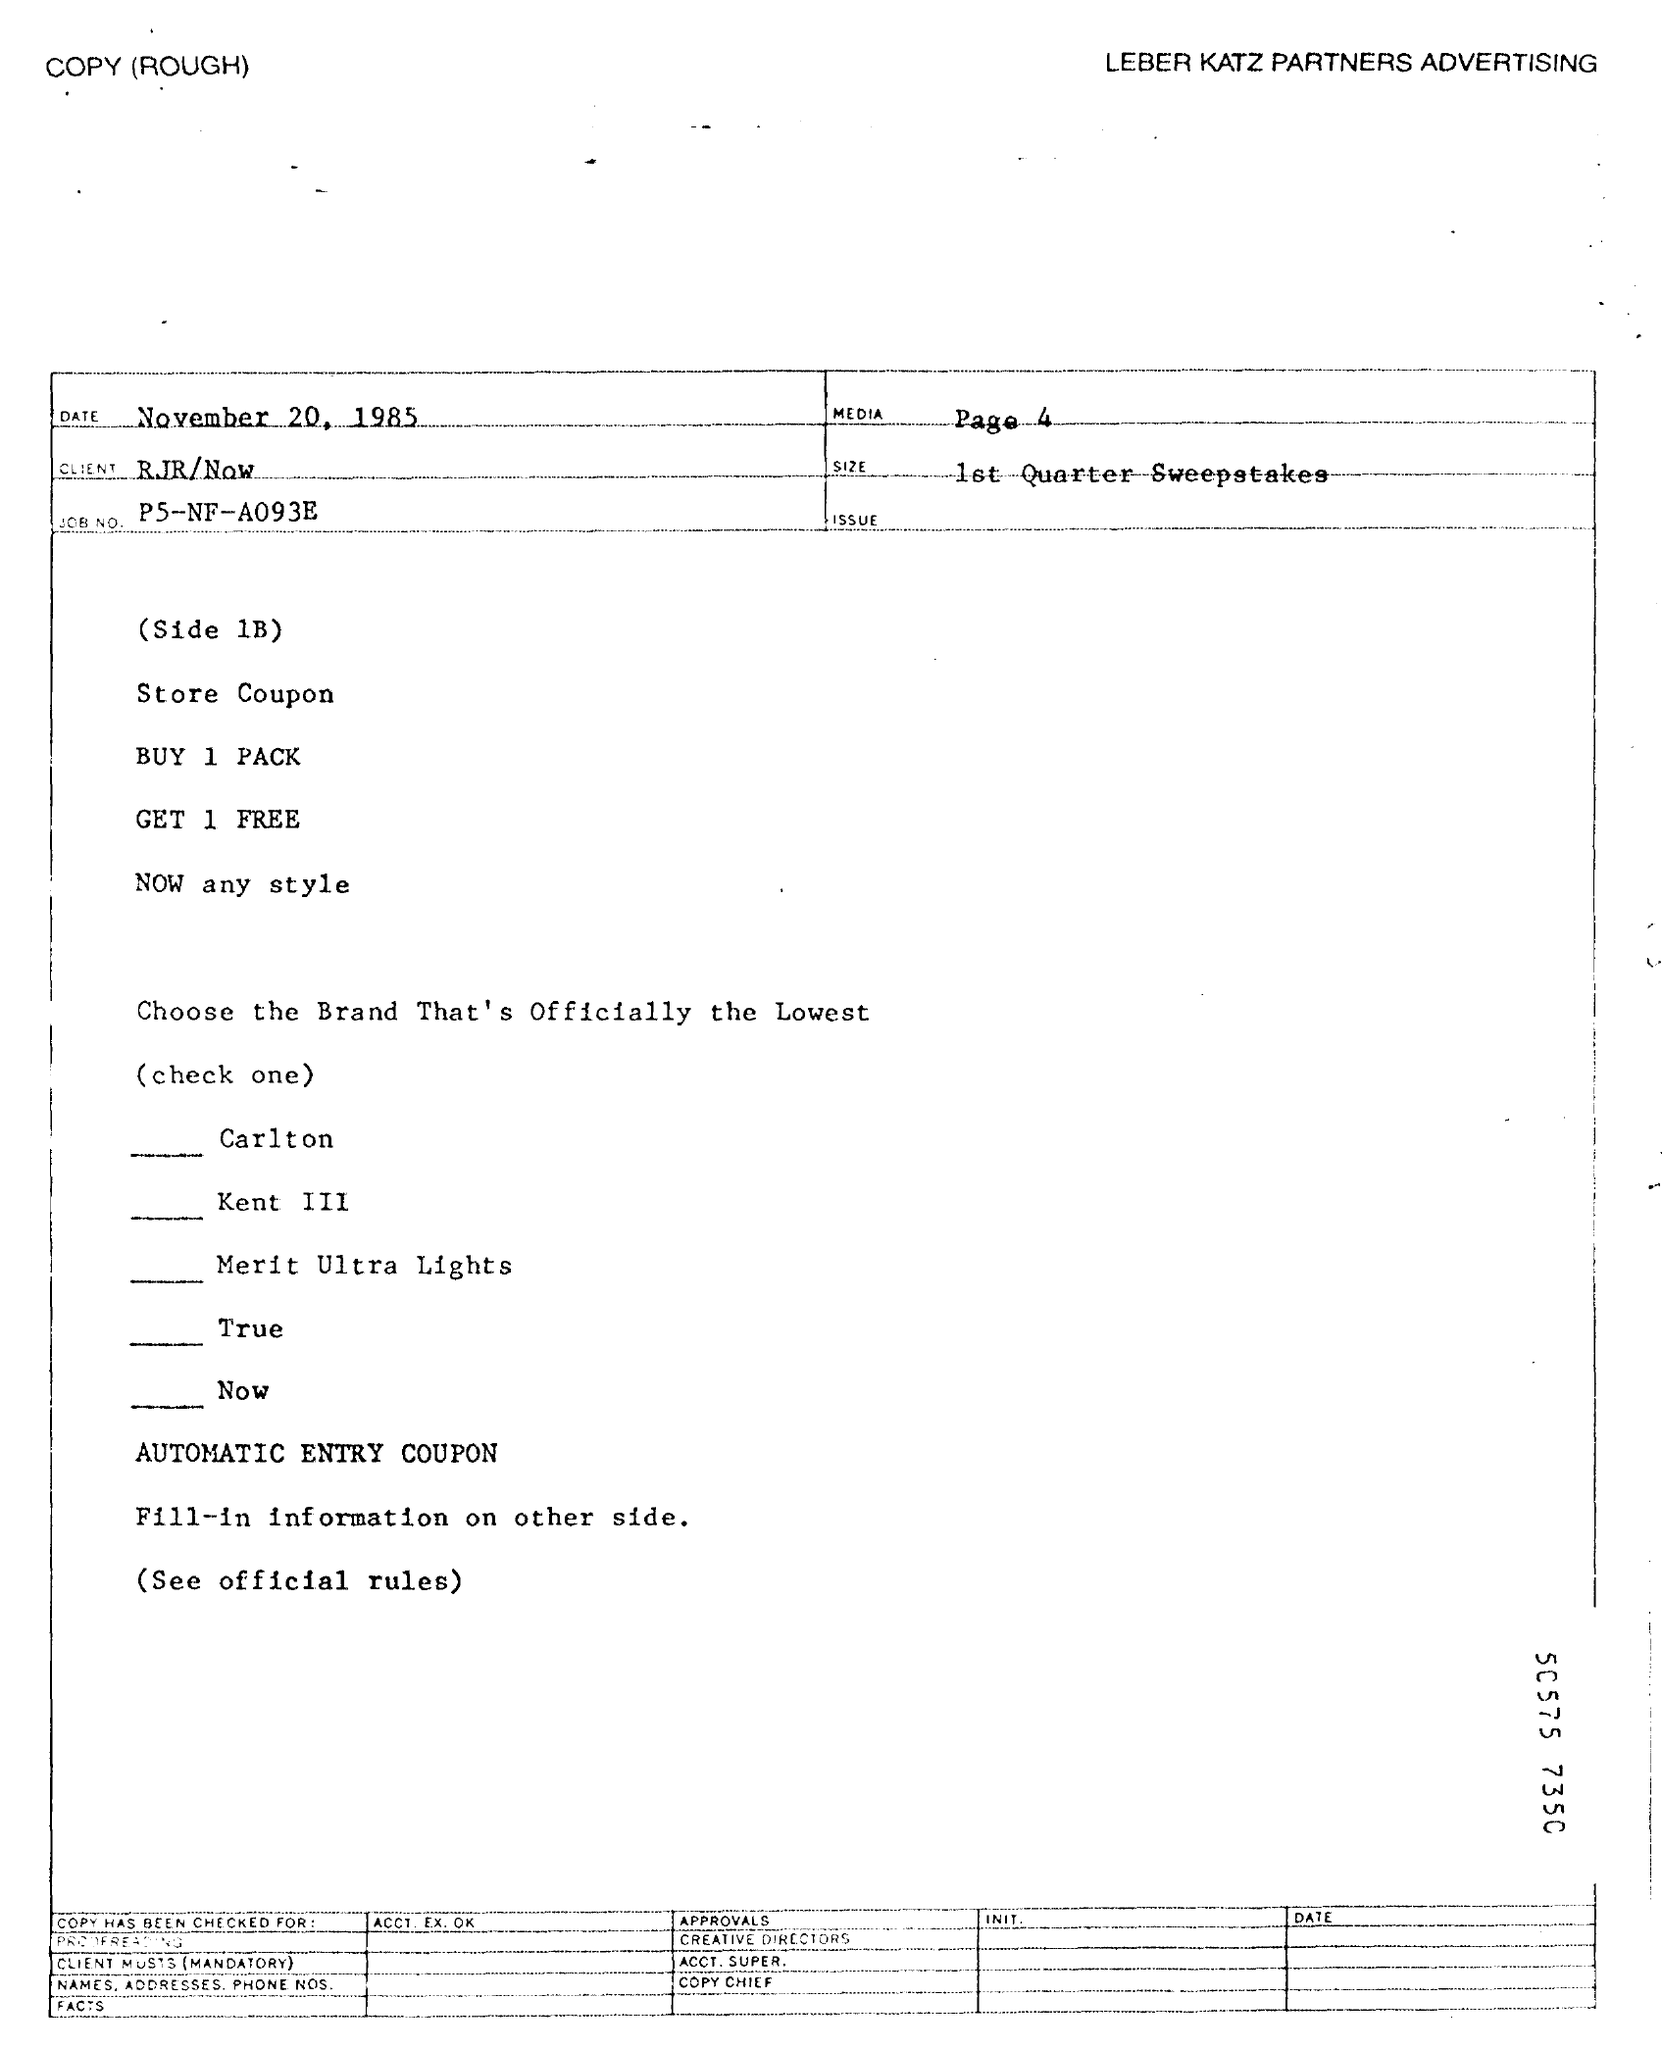Identify some key points in this picture. The client is RJR/Now. The document is dated November 20, 1985. MEDIA is featured on page 4 of the document. The job number is P5-NF-A093E. LEBER KATZ PARTNERS ADVERTISING is the advertising firm that was mentioned. 